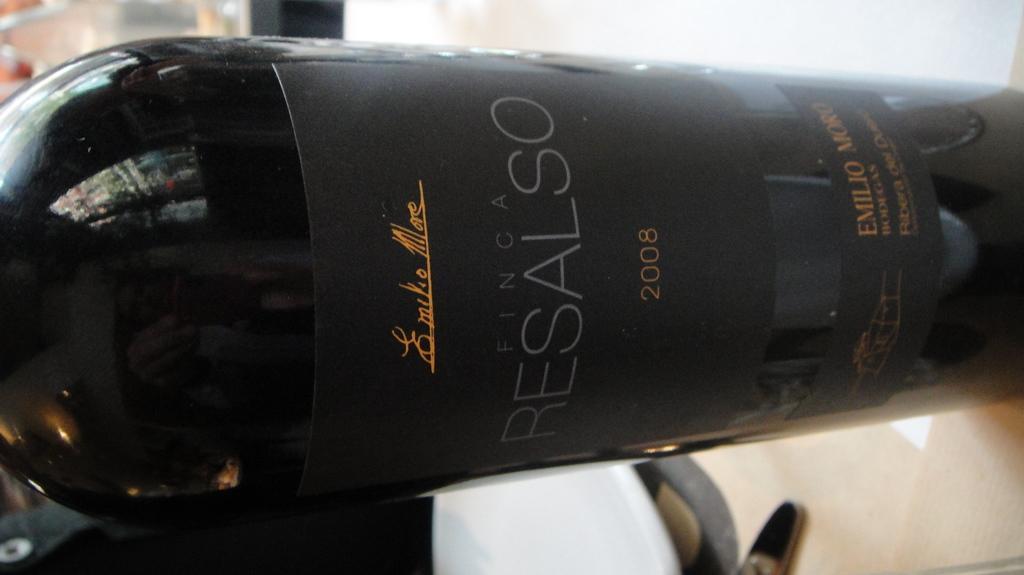In one or two sentences, can you explain what this image depicts? This is a zoomed in picture. In the center there is a black color bottle seems to be placed on the top of the table and we can see the reflection of some objects on the surface of a bottle and there is a paper attached to the bottle on which we can see the text is printed. In the background there are some other objects. 